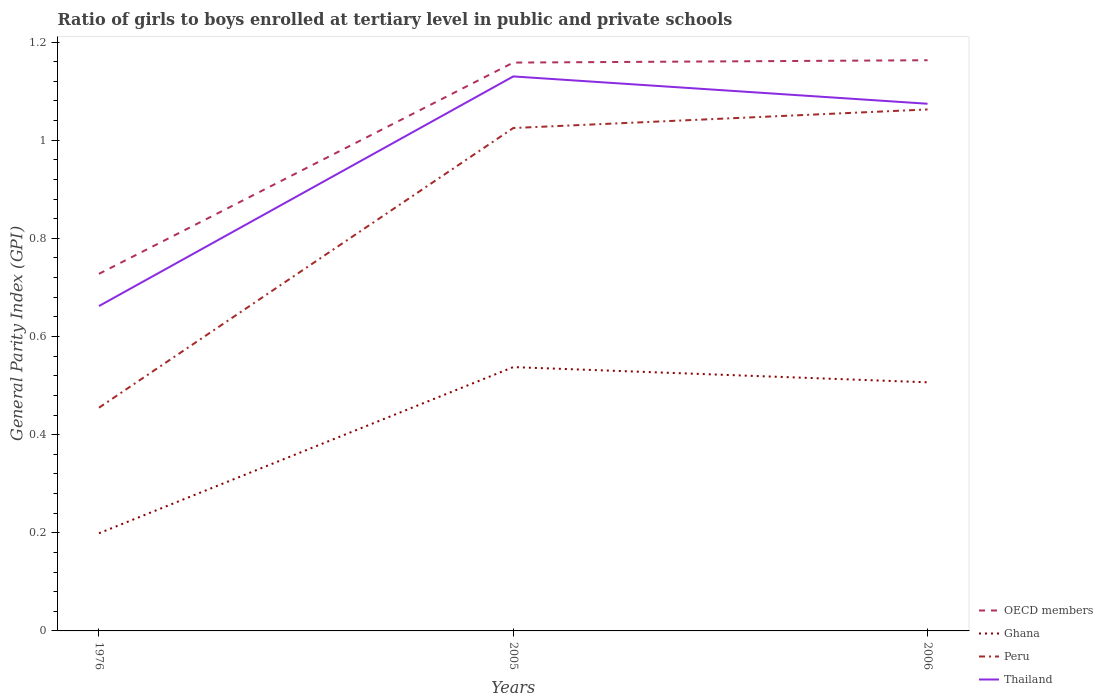How many different coloured lines are there?
Offer a terse response. 4. Across all years, what is the maximum general parity index in Peru?
Offer a very short reply. 0.45. In which year was the general parity index in OECD members maximum?
Offer a very short reply. 1976. What is the total general parity index in Peru in the graph?
Offer a very short reply. -0.04. What is the difference between the highest and the second highest general parity index in Ghana?
Keep it short and to the point. 0.34. What is the difference between the highest and the lowest general parity index in OECD members?
Give a very brief answer. 2. How many lines are there?
Ensure brevity in your answer.  4. How many years are there in the graph?
Provide a short and direct response. 3. How many legend labels are there?
Your answer should be very brief. 4. What is the title of the graph?
Keep it short and to the point. Ratio of girls to boys enrolled at tertiary level in public and private schools. What is the label or title of the X-axis?
Your answer should be very brief. Years. What is the label or title of the Y-axis?
Provide a succinct answer. General Parity Index (GPI). What is the General Parity Index (GPI) in OECD members in 1976?
Keep it short and to the point. 0.73. What is the General Parity Index (GPI) of Ghana in 1976?
Make the answer very short. 0.2. What is the General Parity Index (GPI) in Peru in 1976?
Keep it short and to the point. 0.45. What is the General Parity Index (GPI) in Thailand in 1976?
Provide a short and direct response. 0.66. What is the General Parity Index (GPI) of OECD members in 2005?
Make the answer very short. 1.16. What is the General Parity Index (GPI) of Ghana in 2005?
Give a very brief answer. 0.54. What is the General Parity Index (GPI) of Peru in 2005?
Your response must be concise. 1.02. What is the General Parity Index (GPI) in Thailand in 2005?
Keep it short and to the point. 1.13. What is the General Parity Index (GPI) of OECD members in 2006?
Offer a terse response. 1.16. What is the General Parity Index (GPI) in Ghana in 2006?
Give a very brief answer. 0.51. What is the General Parity Index (GPI) in Peru in 2006?
Your answer should be compact. 1.06. What is the General Parity Index (GPI) of Thailand in 2006?
Give a very brief answer. 1.07. Across all years, what is the maximum General Parity Index (GPI) of OECD members?
Give a very brief answer. 1.16. Across all years, what is the maximum General Parity Index (GPI) of Ghana?
Keep it short and to the point. 0.54. Across all years, what is the maximum General Parity Index (GPI) of Peru?
Your answer should be very brief. 1.06. Across all years, what is the maximum General Parity Index (GPI) of Thailand?
Ensure brevity in your answer.  1.13. Across all years, what is the minimum General Parity Index (GPI) of OECD members?
Offer a very short reply. 0.73. Across all years, what is the minimum General Parity Index (GPI) of Ghana?
Offer a terse response. 0.2. Across all years, what is the minimum General Parity Index (GPI) in Peru?
Provide a succinct answer. 0.45. Across all years, what is the minimum General Parity Index (GPI) in Thailand?
Provide a short and direct response. 0.66. What is the total General Parity Index (GPI) in OECD members in the graph?
Give a very brief answer. 3.05. What is the total General Parity Index (GPI) of Ghana in the graph?
Your answer should be very brief. 1.24. What is the total General Parity Index (GPI) in Peru in the graph?
Make the answer very short. 2.54. What is the total General Parity Index (GPI) of Thailand in the graph?
Your answer should be very brief. 2.87. What is the difference between the General Parity Index (GPI) of OECD members in 1976 and that in 2005?
Offer a terse response. -0.43. What is the difference between the General Parity Index (GPI) of Ghana in 1976 and that in 2005?
Your response must be concise. -0.34. What is the difference between the General Parity Index (GPI) in Peru in 1976 and that in 2005?
Your response must be concise. -0.57. What is the difference between the General Parity Index (GPI) in Thailand in 1976 and that in 2005?
Offer a terse response. -0.47. What is the difference between the General Parity Index (GPI) in OECD members in 1976 and that in 2006?
Ensure brevity in your answer.  -0.44. What is the difference between the General Parity Index (GPI) of Ghana in 1976 and that in 2006?
Your answer should be very brief. -0.31. What is the difference between the General Parity Index (GPI) in Peru in 1976 and that in 2006?
Provide a short and direct response. -0.61. What is the difference between the General Parity Index (GPI) in Thailand in 1976 and that in 2006?
Your answer should be very brief. -0.41. What is the difference between the General Parity Index (GPI) of OECD members in 2005 and that in 2006?
Make the answer very short. -0. What is the difference between the General Parity Index (GPI) in Ghana in 2005 and that in 2006?
Offer a terse response. 0.03. What is the difference between the General Parity Index (GPI) of Peru in 2005 and that in 2006?
Keep it short and to the point. -0.04. What is the difference between the General Parity Index (GPI) of Thailand in 2005 and that in 2006?
Provide a short and direct response. 0.06. What is the difference between the General Parity Index (GPI) of OECD members in 1976 and the General Parity Index (GPI) of Ghana in 2005?
Offer a terse response. 0.19. What is the difference between the General Parity Index (GPI) of OECD members in 1976 and the General Parity Index (GPI) of Peru in 2005?
Provide a succinct answer. -0.3. What is the difference between the General Parity Index (GPI) in OECD members in 1976 and the General Parity Index (GPI) in Thailand in 2005?
Your answer should be very brief. -0.4. What is the difference between the General Parity Index (GPI) of Ghana in 1976 and the General Parity Index (GPI) of Peru in 2005?
Your answer should be very brief. -0.83. What is the difference between the General Parity Index (GPI) in Ghana in 1976 and the General Parity Index (GPI) in Thailand in 2005?
Give a very brief answer. -0.93. What is the difference between the General Parity Index (GPI) in Peru in 1976 and the General Parity Index (GPI) in Thailand in 2005?
Provide a succinct answer. -0.68. What is the difference between the General Parity Index (GPI) of OECD members in 1976 and the General Parity Index (GPI) of Ghana in 2006?
Your response must be concise. 0.22. What is the difference between the General Parity Index (GPI) in OECD members in 1976 and the General Parity Index (GPI) in Peru in 2006?
Offer a very short reply. -0.34. What is the difference between the General Parity Index (GPI) of OECD members in 1976 and the General Parity Index (GPI) of Thailand in 2006?
Offer a terse response. -0.35. What is the difference between the General Parity Index (GPI) of Ghana in 1976 and the General Parity Index (GPI) of Peru in 2006?
Make the answer very short. -0.86. What is the difference between the General Parity Index (GPI) in Ghana in 1976 and the General Parity Index (GPI) in Thailand in 2006?
Offer a terse response. -0.88. What is the difference between the General Parity Index (GPI) in Peru in 1976 and the General Parity Index (GPI) in Thailand in 2006?
Provide a succinct answer. -0.62. What is the difference between the General Parity Index (GPI) of OECD members in 2005 and the General Parity Index (GPI) of Ghana in 2006?
Provide a short and direct response. 0.65. What is the difference between the General Parity Index (GPI) in OECD members in 2005 and the General Parity Index (GPI) in Peru in 2006?
Give a very brief answer. 0.1. What is the difference between the General Parity Index (GPI) in OECD members in 2005 and the General Parity Index (GPI) in Thailand in 2006?
Offer a very short reply. 0.08. What is the difference between the General Parity Index (GPI) of Ghana in 2005 and the General Parity Index (GPI) of Peru in 2006?
Provide a short and direct response. -0.53. What is the difference between the General Parity Index (GPI) of Ghana in 2005 and the General Parity Index (GPI) of Thailand in 2006?
Your answer should be very brief. -0.54. What is the difference between the General Parity Index (GPI) in Peru in 2005 and the General Parity Index (GPI) in Thailand in 2006?
Provide a succinct answer. -0.05. What is the average General Parity Index (GPI) of OECD members per year?
Your answer should be compact. 1.02. What is the average General Parity Index (GPI) in Ghana per year?
Your answer should be compact. 0.41. What is the average General Parity Index (GPI) of Peru per year?
Make the answer very short. 0.85. What is the average General Parity Index (GPI) of Thailand per year?
Offer a very short reply. 0.96. In the year 1976, what is the difference between the General Parity Index (GPI) of OECD members and General Parity Index (GPI) of Ghana?
Your response must be concise. 0.53. In the year 1976, what is the difference between the General Parity Index (GPI) of OECD members and General Parity Index (GPI) of Peru?
Offer a terse response. 0.27. In the year 1976, what is the difference between the General Parity Index (GPI) in OECD members and General Parity Index (GPI) in Thailand?
Provide a succinct answer. 0.07. In the year 1976, what is the difference between the General Parity Index (GPI) of Ghana and General Parity Index (GPI) of Peru?
Provide a short and direct response. -0.26. In the year 1976, what is the difference between the General Parity Index (GPI) in Ghana and General Parity Index (GPI) in Thailand?
Make the answer very short. -0.46. In the year 1976, what is the difference between the General Parity Index (GPI) of Peru and General Parity Index (GPI) of Thailand?
Your answer should be very brief. -0.21. In the year 2005, what is the difference between the General Parity Index (GPI) in OECD members and General Parity Index (GPI) in Ghana?
Provide a short and direct response. 0.62. In the year 2005, what is the difference between the General Parity Index (GPI) of OECD members and General Parity Index (GPI) of Peru?
Offer a terse response. 0.13. In the year 2005, what is the difference between the General Parity Index (GPI) of OECD members and General Parity Index (GPI) of Thailand?
Keep it short and to the point. 0.03. In the year 2005, what is the difference between the General Parity Index (GPI) of Ghana and General Parity Index (GPI) of Peru?
Ensure brevity in your answer.  -0.49. In the year 2005, what is the difference between the General Parity Index (GPI) in Ghana and General Parity Index (GPI) in Thailand?
Make the answer very short. -0.59. In the year 2005, what is the difference between the General Parity Index (GPI) in Peru and General Parity Index (GPI) in Thailand?
Provide a succinct answer. -0.11. In the year 2006, what is the difference between the General Parity Index (GPI) of OECD members and General Parity Index (GPI) of Ghana?
Provide a short and direct response. 0.66. In the year 2006, what is the difference between the General Parity Index (GPI) of OECD members and General Parity Index (GPI) of Peru?
Provide a short and direct response. 0.1. In the year 2006, what is the difference between the General Parity Index (GPI) in OECD members and General Parity Index (GPI) in Thailand?
Ensure brevity in your answer.  0.09. In the year 2006, what is the difference between the General Parity Index (GPI) in Ghana and General Parity Index (GPI) in Peru?
Offer a terse response. -0.56. In the year 2006, what is the difference between the General Parity Index (GPI) in Ghana and General Parity Index (GPI) in Thailand?
Your response must be concise. -0.57. In the year 2006, what is the difference between the General Parity Index (GPI) in Peru and General Parity Index (GPI) in Thailand?
Keep it short and to the point. -0.01. What is the ratio of the General Parity Index (GPI) of OECD members in 1976 to that in 2005?
Give a very brief answer. 0.63. What is the ratio of the General Parity Index (GPI) of Ghana in 1976 to that in 2005?
Make the answer very short. 0.37. What is the ratio of the General Parity Index (GPI) in Peru in 1976 to that in 2005?
Ensure brevity in your answer.  0.44. What is the ratio of the General Parity Index (GPI) in Thailand in 1976 to that in 2005?
Your answer should be compact. 0.59. What is the ratio of the General Parity Index (GPI) of OECD members in 1976 to that in 2006?
Your answer should be very brief. 0.63. What is the ratio of the General Parity Index (GPI) in Ghana in 1976 to that in 2006?
Ensure brevity in your answer.  0.39. What is the ratio of the General Parity Index (GPI) of Peru in 1976 to that in 2006?
Keep it short and to the point. 0.43. What is the ratio of the General Parity Index (GPI) in Thailand in 1976 to that in 2006?
Your answer should be very brief. 0.62. What is the ratio of the General Parity Index (GPI) in OECD members in 2005 to that in 2006?
Offer a terse response. 1. What is the ratio of the General Parity Index (GPI) in Ghana in 2005 to that in 2006?
Offer a very short reply. 1.06. What is the ratio of the General Parity Index (GPI) in Peru in 2005 to that in 2006?
Your answer should be compact. 0.96. What is the ratio of the General Parity Index (GPI) in Thailand in 2005 to that in 2006?
Offer a very short reply. 1.05. What is the difference between the highest and the second highest General Parity Index (GPI) of OECD members?
Offer a very short reply. 0. What is the difference between the highest and the second highest General Parity Index (GPI) of Ghana?
Your response must be concise. 0.03. What is the difference between the highest and the second highest General Parity Index (GPI) in Peru?
Keep it short and to the point. 0.04. What is the difference between the highest and the second highest General Parity Index (GPI) in Thailand?
Your response must be concise. 0.06. What is the difference between the highest and the lowest General Parity Index (GPI) in OECD members?
Your answer should be very brief. 0.44. What is the difference between the highest and the lowest General Parity Index (GPI) of Ghana?
Offer a very short reply. 0.34. What is the difference between the highest and the lowest General Parity Index (GPI) of Peru?
Offer a very short reply. 0.61. What is the difference between the highest and the lowest General Parity Index (GPI) in Thailand?
Make the answer very short. 0.47. 